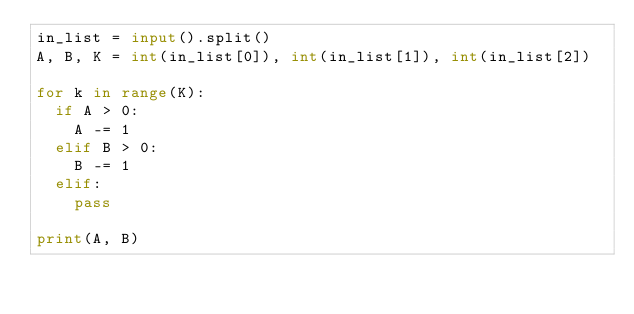Convert code to text. <code><loc_0><loc_0><loc_500><loc_500><_Python_>in_list = input().split()
A, B, K = int(in_list[0]), int(in_list[1]), int(in_list[2])

for k in range(K):
  if A > 0:
    A -= 1
  elif B > 0:
    B -= 1
  elif:
    pass

print(A, B)
</code> 